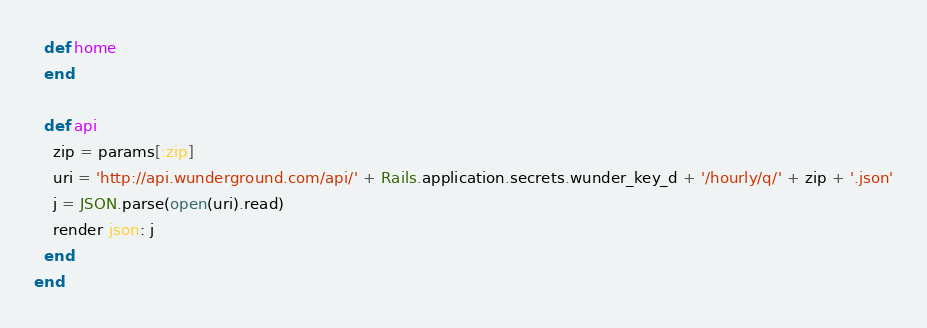<code> <loc_0><loc_0><loc_500><loc_500><_Ruby_>  def home
  end

  def api
    zip = params[:zip]
    uri = 'http://api.wunderground.com/api/' + Rails.application.secrets.wunder_key_d + '/hourly/q/' + zip + '.json'
    j = JSON.parse(open(uri).read)
    render json: j
  end
end
</code> 